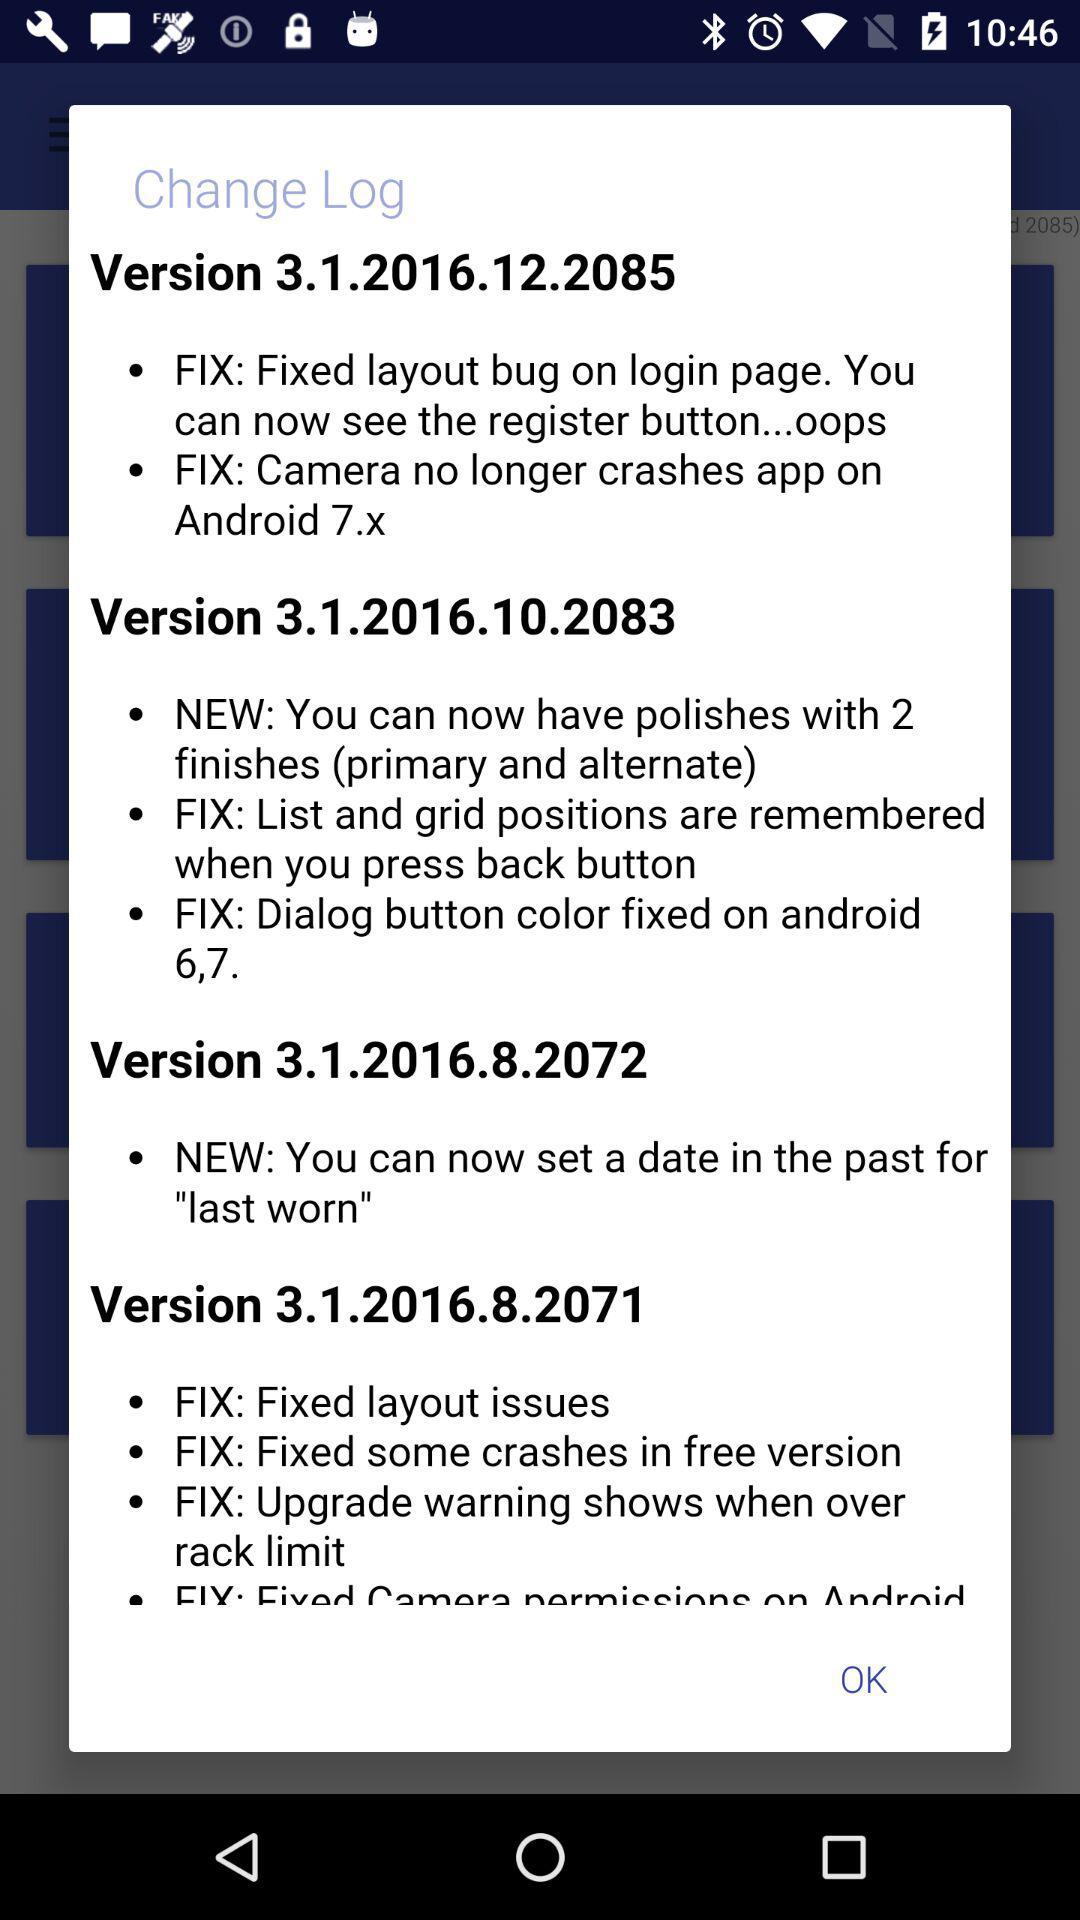Who is the user?
When the provided information is insufficient, respond with <no answer>. <no answer> 